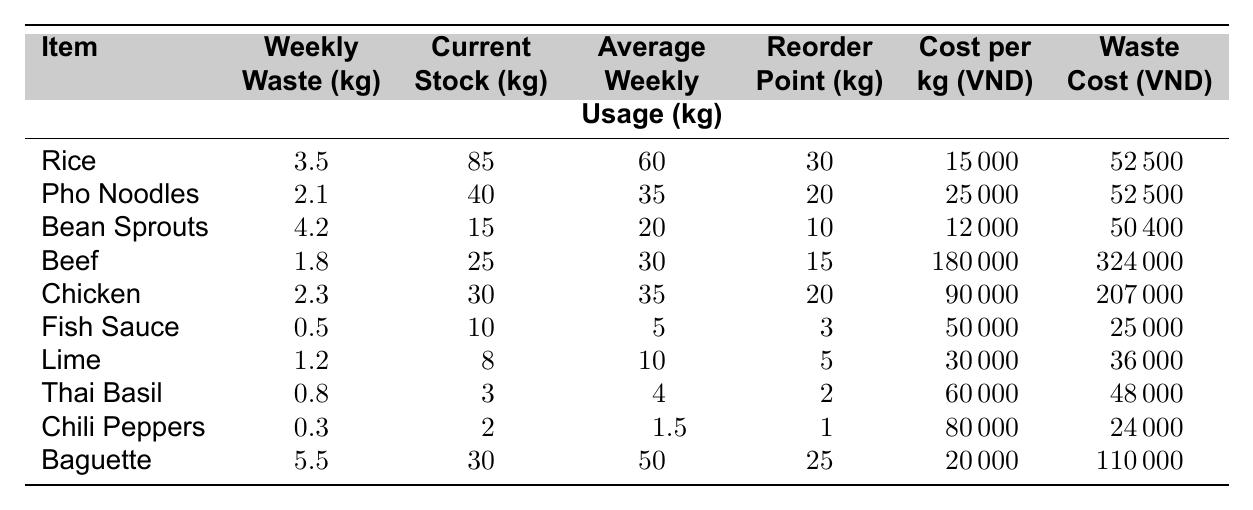What is the weekly waste of rice? The table shows the weekly waste for rice under the column "Weekly Waste (kg)," which is 3.5 kg.
Answer: 3.5 kg How much is the waste cost for bean sprouts? The waste cost for bean sprouts can be found in the "Waste Cost (VND)" column, which lists a value of 50400 VND.
Answer: 50400 VND What is the total weekly waste of chicken and beef combined? Add the weekly waste of chicken (2.3 kg) to that of beef (1.8 kg): 2.3 + 1.8 = 4.1 kg.
Answer: 4.1 kg Is the current stock of fish sauce greater than the reorder point? The current stock of fish sauce is 10 kg, and the reorder point is 3 kg; since 10 > 3, the statement is true.
Answer: Yes How much does it cost in VND for 1 kg of Thai basil? The table lists the cost per kg of Thai basil in the "Cost per kg (VND)" column, which is 60000 VND.
Answer: 60000 VND What is the average weekly usage of pho noodles? The average weekly usage of pho noodles is found in the "Average Weekly Usage (kg)" column, which shows a value of 35 kg.
Answer: 35 kg Which item has the highest waste cost? By comparing the waste costs in the "Waste Cost (VND)" column, beef has the highest cost at 324000 VND.
Answer: Beef What is the total cost of waste for all items listed? Sum the waste costs of all items: 52500 + 52500 + 50400 + 324000 + 207000 + 25000 + 36000 + 48000 + 24000 + 110000 =  799400 VND.
Answer: 799400 VND Does the weekly waste of lime exceed its average weekly usage? The weekly waste of lime is 1.2 kg, and its average weekly usage is 10 kg; since 1.2 < 10, the statement is false.
Answer: No If the current stock of rice is reduced by the weekly waste, what will be the remaining stock? Subtract the weekly waste of rice (3.5 kg) from the current stock (85 kg): 85 - 3.5 = 81.5 kg.
Answer: 81.5 kg 